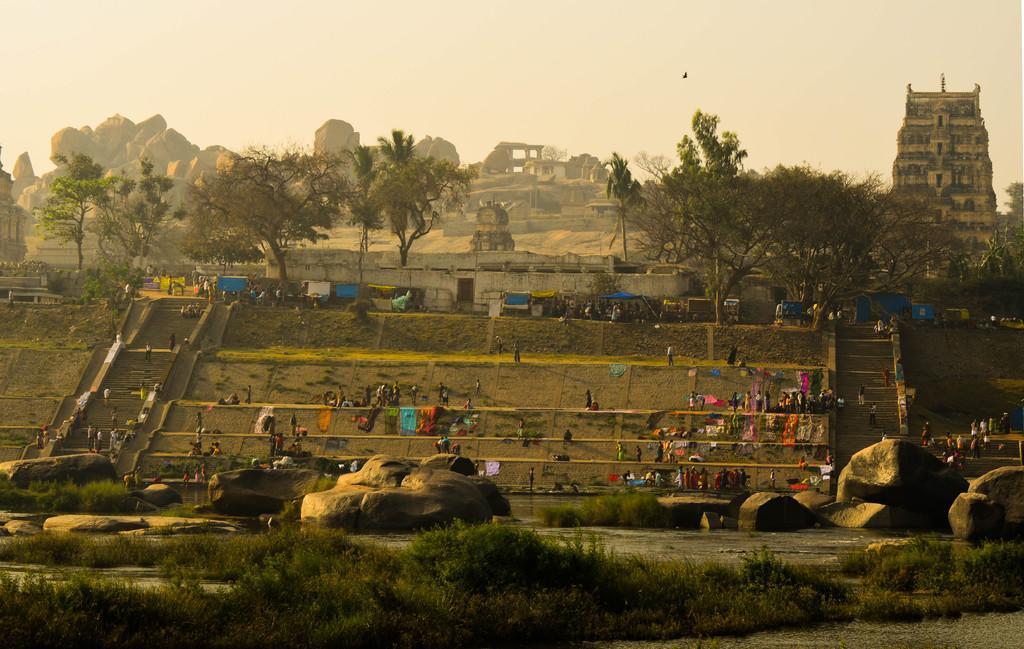Can you describe this image briefly? This image consists of a temple. There are stairs on the left side and right side. There are so many people standing in the middle. There is water at the bottom. There are trees in the middle. There are bushes at the bottom. There is temple on the right side. There is sky at the top. 